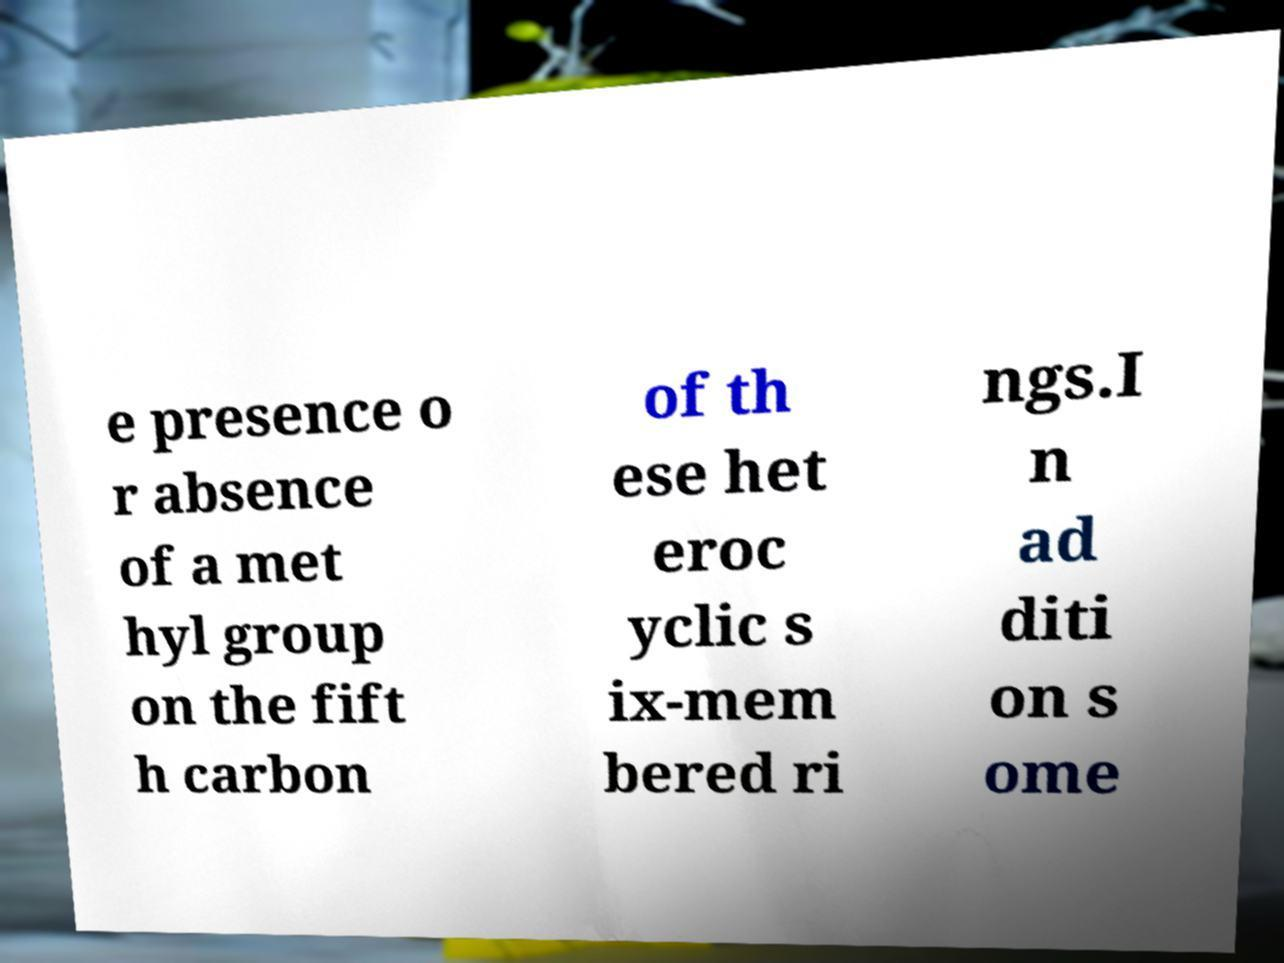For documentation purposes, I need the text within this image transcribed. Could you provide that? e presence o r absence of a met hyl group on the fift h carbon of th ese het eroc yclic s ix-mem bered ri ngs.I n ad diti on s ome 